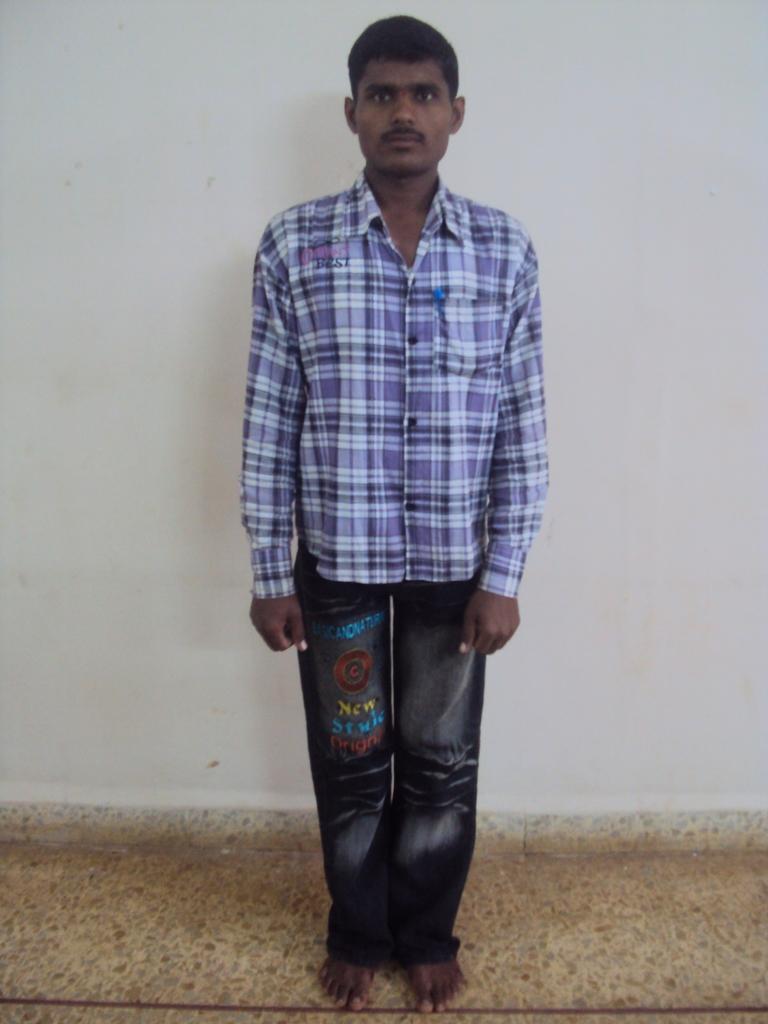Please provide a concise description of this image. This image consists of a man wearing blue shirt and jeans. At the bottom, there is a floor. In the background, there is a wall. 